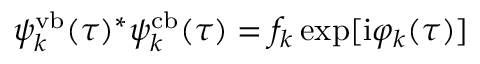<formula> <loc_0><loc_0><loc_500><loc_500>\psi _ { k } ^ { v b } ( \tau ) ^ { * } \psi _ { k } ^ { c b } ( \tau ) = f _ { k } \exp [ i \varphi _ { k } ( \tau ) ]</formula> 